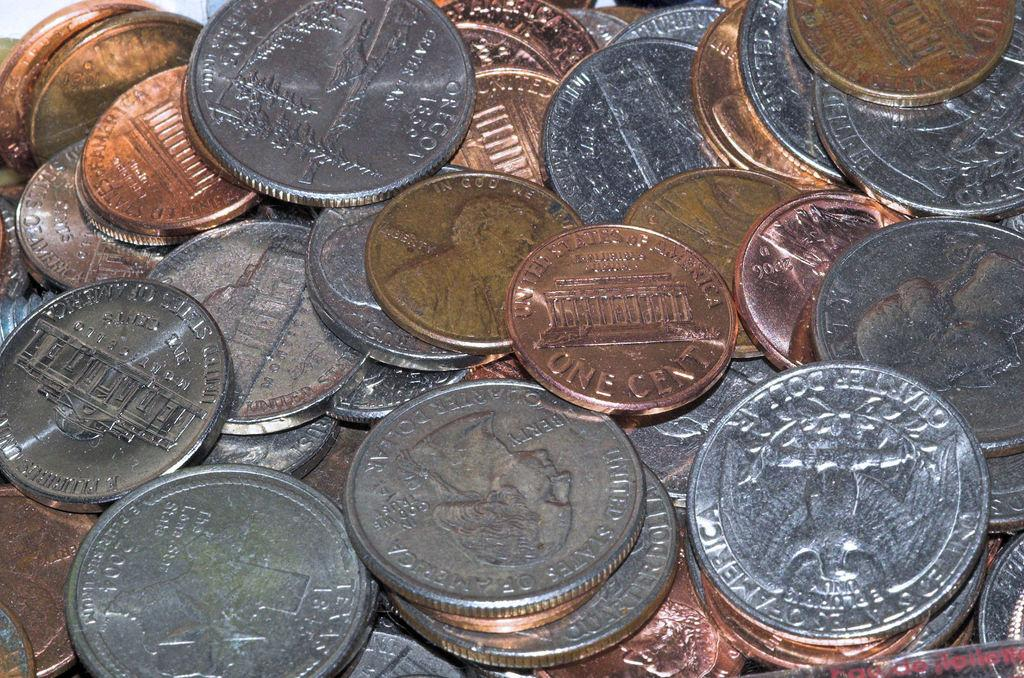How many coins are visible in the image? There are three coins in the image. What can be observed about the appearance of the coins? The coins have different colors. Is there a cave in the background of the image? There is no cave present in the image. What type of plastic object can be seen in the image? There is no plastic object present in the image. 